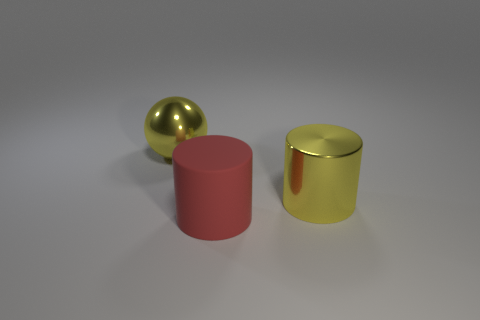Does the thing that is to the right of the big red matte thing have the same color as the thing that is to the left of the red rubber thing?
Your answer should be very brief. Yes. What is the color of the other object that is the same shape as the rubber thing?
Your answer should be compact. Yellow. Is there anything else that is the same shape as the big red rubber object?
Make the answer very short. Yes. There is a yellow shiny object that is in front of the shiny ball; does it have the same shape as the large yellow metal thing that is on the left side of the red cylinder?
Offer a terse response. No. There is a ball; is its size the same as the yellow metallic object on the right side of the yellow metallic sphere?
Provide a short and direct response. Yes. Are there more yellow shiny balls than cylinders?
Make the answer very short. No. Are the big yellow object that is left of the large yellow metal cylinder and the yellow thing on the right side of the ball made of the same material?
Keep it short and to the point. Yes. What is the material of the yellow sphere?
Provide a short and direct response. Metal. Are there more rubber cylinders to the right of the metallic sphere than purple matte cubes?
Offer a very short reply. Yes. There is a thing that is in front of the large shiny object that is in front of the large yellow sphere; what number of cylinders are in front of it?
Make the answer very short. 0. 